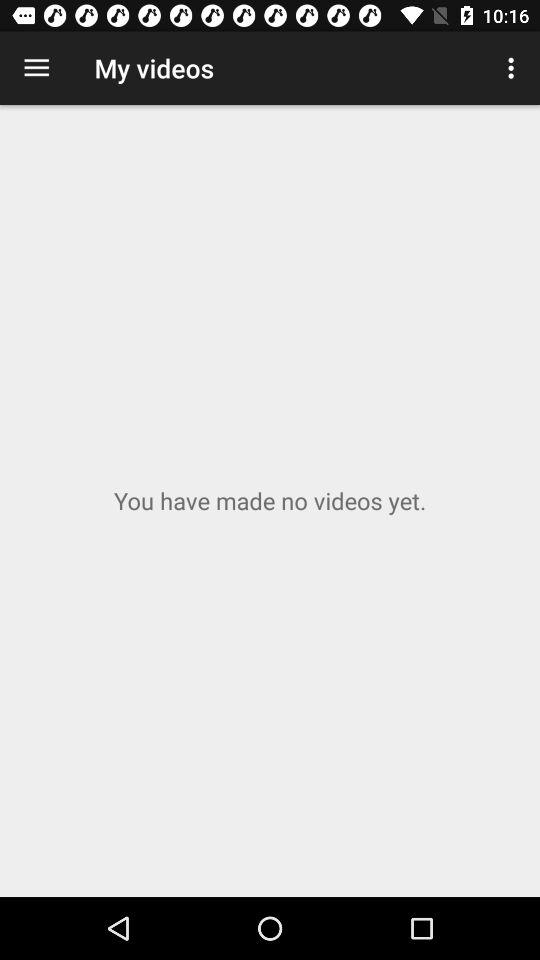How many videos have been made?
Answer the question using a single word or phrase. 0 